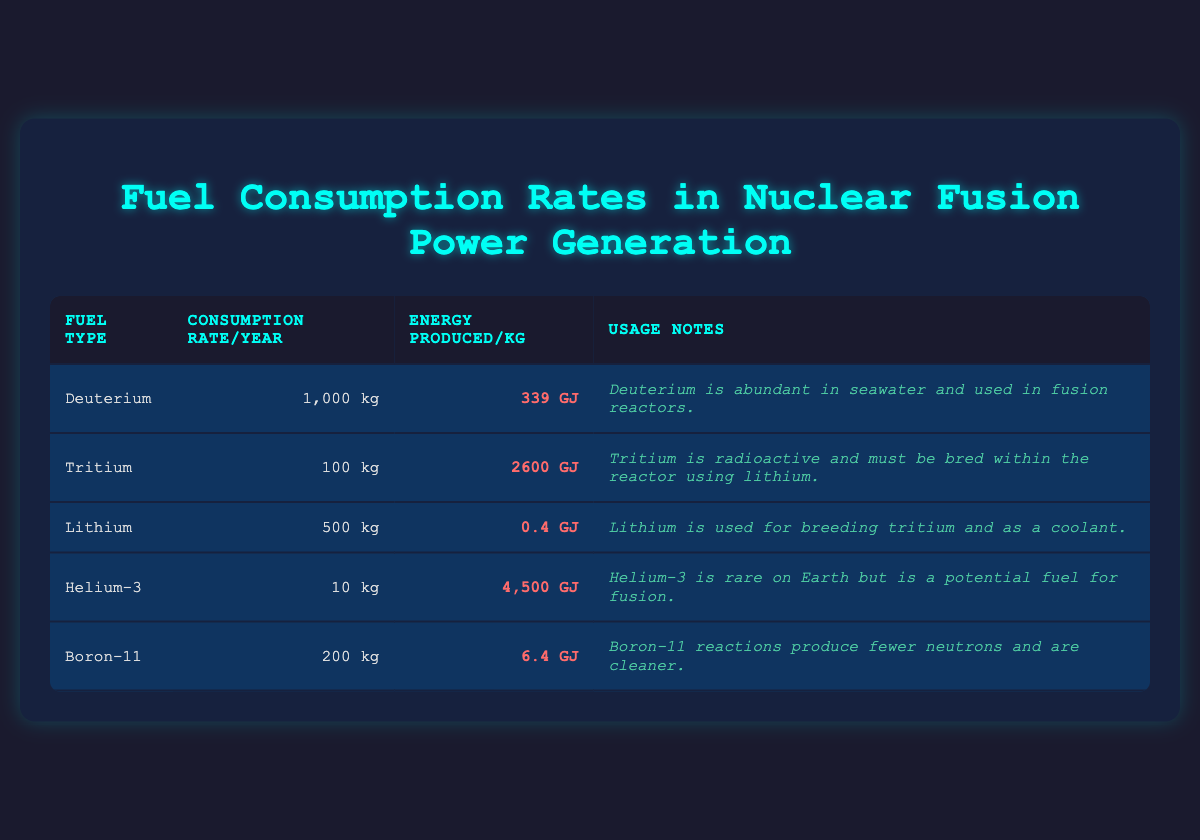What is the consumption rate of Deuterium per year? The table specifically lists Deuterium's consumption rate under the "Consumption Rate/Year" column as 1,000 kg.
Answer: 1,000 kg Which fuel type produces the most energy per kilogram? Comparing the "Energy Produced/kg" values, Helium-3 has the highest value at 4,500 GJ, which is greater than any other fuel type listed.
Answer: Helium-3 What is the combined yearly consumption rate of Tritium and Lithium? The consumption rate for Tritium is 100 kg and for Lithium is 500 kg. Adding these gives 100 + 500 = 600 kg.
Answer: 600 kg Is Tritium considered a non-radioactive fuel? The usage notes for Tritium clearly state that it is radioactive, so it is not non-radioactive.
Answer: No What is the total energy produced by Deuterium and Tritium combined? Deuterium produces 339 GJ/kg and Tritium produces 2,600 GJ/kg. The total energy is (339 + 2600) GJ = 2,939 GJ.
Answer: 2,939 GJ Which fuel type has the lowest energy produced per kilogram? Lithium has the lowest energy produced value of 0.4 GJ/kg, which is less than the other fuels.
Answer: Lithium If all fuels were consumed for a year, which one would require the largest quantity? Deuterium requires 1,000 kg per year, which is the largest compared to the other fuels' consumption rates.
Answer: Deuterium What fraction of the yearly consumption of Tritium does Helium-3 account for? Helium-3 has a consumption rate of 10 kg, and Tritium has 100 kg. The fraction is 10 kg / 100 kg = 0.1 or 10%.
Answer: 10% How many more kilograms of Lithium are consumed compared to Helium-3? Lithium consumption is 500 kg and Helium-3 is 10 kg. The difference is 500 - 10 = 490 kg.
Answer: 490 kg Which fuel has the highest energy output and what is the value? Helium-3 has the highest energy output at 4,500 GJ per kilogram, according to the table.
Answer: Helium-3, 4,500 GJ 